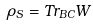<formula> <loc_0><loc_0><loc_500><loc_500>\rho _ { S } = T r _ { B C } W</formula> 